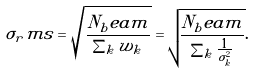Convert formula to latex. <formula><loc_0><loc_0><loc_500><loc_500>\sigma _ { r } m s = \sqrt { \frac { N _ { b } e a m } { \sum _ { k } w _ { k } } } = \sqrt { \frac { N _ { b } e a m } { \sum _ { k } \frac { 1 } { \sigma _ { k } ^ { 2 } } } } .</formula> 